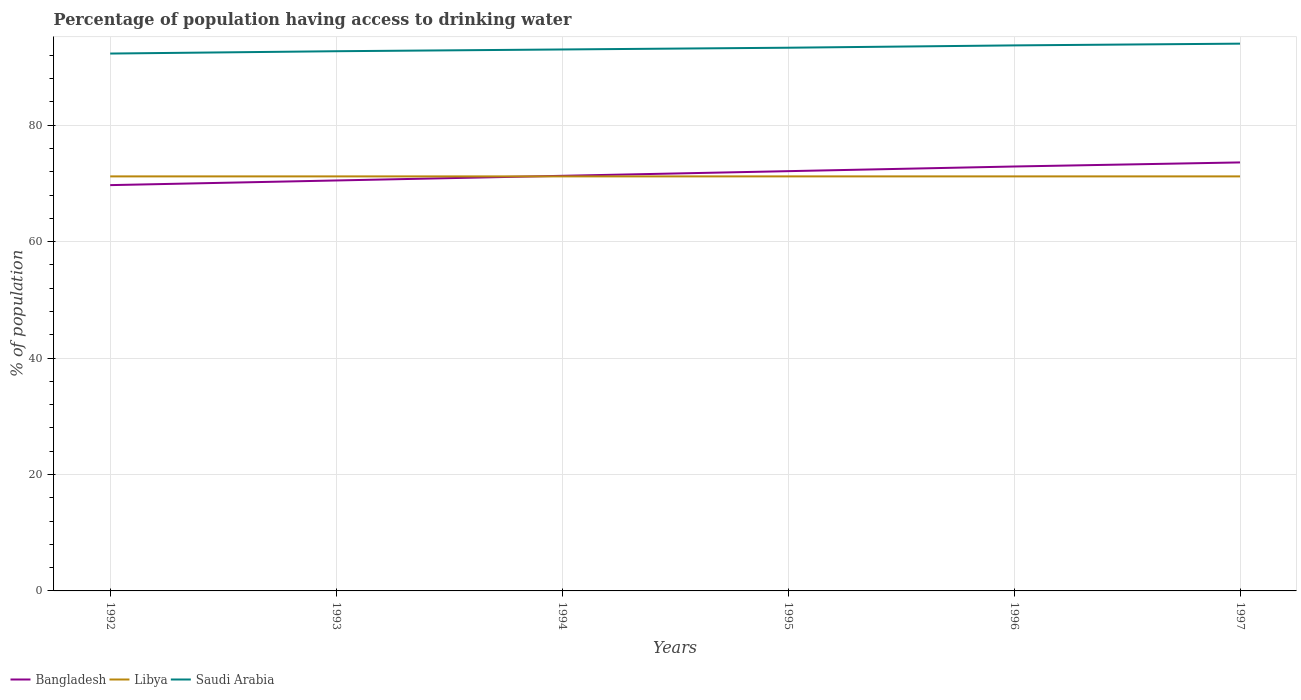How many different coloured lines are there?
Offer a terse response. 3. Is the number of lines equal to the number of legend labels?
Provide a short and direct response. Yes. Across all years, what is the maximum percentage of population having access to drinking water in Bangladesh?
Your answer should be very brief. 69.7. In which year was the percentage of population having access to drinking water in Saudi Arabia maximum?
Give a very brief answer. 1992. What is the total percentage of population having access to drinking water in Bangladesh in the graph?
Ensure brevity in your answer.  -1.6. What is the difference between the highest and the second highest percentage of population having access to drinking water in Saudi Arabia?
Your answer should be compact. 1.7. How many lines are there?
Your answer should be very brief. 3. What is the difference between two consecutive major ticks on the Y-axis?
Offer a terse response. 20. Are the values on the major ticks of Y-axis written in scientific E-notation?
Give a very brief answer. No. Does the graph contain any zero values?
Provide a succinct answer. No. Does the graph contain grids?
Offer a terse response. Yes. How are the legend labels stacked?
Offer a very short reply. Horizontal. What is the title of the graph?
Offer a terse response. Percentage of population having access to drinking water. Does "Middle East & North Africa (developing only)" appear as one of the legend labels in the graph?
Give a very brief answer. No. What is the label or title of the X-axis?
Make the answer very short. Years. What is the label or title of the Y-axis?
Your response must be concise. % of population. What is the % of population of Bangladesh in 1992?
Offer a very short reply. 69.7. What is the % of population in Libya in 1992?
Ensure brevity in your answer.  71.2. What is the % of population of Saudi Arabia in 1992?
Give a very brief answer. 92.3. What is the % of population in Bangladesh in 1993?
Provide a short and direct response. 70.5. What is the % of population in Libya in 1993?
Offer a very short reply. 71.2. What is the % of population of Saudi Arabia in 1993?
Offer a terse response. 92.7. What is the % of population in Bangladesh in 1994?
Ensure brevity in your answer.  71.3. What is the % of population in Libya in 1994?
Give a very brief answer. 71.2. What is the % of population of Saudi Arabia in 1994?
Give a very brief answer. 93. What is the % of population in Bangladesh in 1995?
Ensure brevity in your answer.  72.1. What is the % of population of Libya in 1995?
Your answer should be very brief. 71.2. What is the % of population in Saudi Arabia in 1995?
Offer a very short reply. 93.3. What is the % of population of Bangladesh in 1996?
Give a very brief answer. 72.9. What is the % of population of Libya in 1996?
Keep it short and to the point. 71.2. What is the % of population of Saudi Arabia in 1996?
Your response must be concise. 93.7. What is the % of population of Bangladesh in 1997?
Offer a terse response. 73.6. What is the % of population in Libya in 1997?
Your answer should be compact. 71.2. What is the % of population in Saudi Arabia in 1997?
Provide a short and direct response. 94. Across all years, what is the maximum % of population of Bangladesh?
Provide a succinct answer. 73.6. Across all years, what is the maximum % of population of Libya?
Your answer should be very brief. 71.2. Across all years, what is the maximum % of population in Saudi Arabia?
Offer a terse response. 94. Across all years, what is the minimum % of population in Bangladesh?
Offer a terse response. 69.7. Across all years, what is the minimum % of population in Libya?
Give a very brief answer. 71.2. Across all years, what is the minimum % of population in Saudi Arabia?
Provide a succinct answer. 92.3. What is the total % of population of Bangladesh in the graph?
Make the answer very short. 430.1. What is the total % of population in Libya in the graph?
Your response must be concise. 427.2. What is the total % of population of Saudi Arabia in the graph?
Your response must be concise. 559. What is the difference between the % of population in Bangladesh in 1992 and that in 1993?
Your response must be concise. -0.8. What is the difference between the % of population in Bangladesh in 1992 and that in 1994?
Offer a very short reply. -1.6. What is the difference between the % of population in Saudi Arabia in 1992 and that in 1994?
Your response must be concise. -0.7. What is the difference between the % of population of Libya in 1992 and that in 1995?
Your answer should be very brief. 0. What is the difference between the % of population in Libya in 1992 and that in 1996?
Provide a succinct answer. 0. What is the difference between the % of population of Saudi Arabia in 1992 and that in 1996?
Provide a succinct answer. -1.4. What is the difference between the % of population in Libya in 1992 and that in 1997?
Your answer should be compact. 0. What is the difference between the % of population of Bangladesh in 1993 and that in 1994?
Your response must be concise. -0.8. What is the difference between the % of population of Libya in 1993 and that in 1994?
Your answer should be very brief. 0. What is the difference between the % of population of Saudi Arabia in 1993 and that in 1994?
Provide a succinct answer. -0.3. What is the difference between the % of population in Bangladesh in 1993 and that in 1996?
Your answer should be very brief. -2.4. What is the difference between the % of population of Bangladesh in 1993 and that in 1997?
Give a very brief answer. -3.1. What is the difference between the % of population of Libya in 1993 and that in 1997?
Your response must be concise. 0. What is the difference between the % of population of Saudi Arabia in 1993 and that in 1997?
Provide a short and direct response. -1.3. What is the difference between the % of population in Bangladesh in 1994 and that in 1995?
Offer a terse response. -0.8. What is the difference between the % of population in Libya in 1994 and that in 1995?
Your response must be concise. 0. What is the difference between the % of population of Saudi Arabia in 1994 and that in 1995?
Offer a terse response. -0.3. What is the difference between the % of population of Bangladesh in 1994 and that in 1996?
Your answer should be compact. -1.6. What is the difference between the % of population in Libya in 1994 and that in 1996?
Give a very brief answer. 0. What is the difference between the % of population in Saudi Arabia in 1994 and that in 1996?
Offer a very short reply. -0.7. What is the difference between the % of population of Bangladesh in 1994 and that in 1997?
Keep it short and to the point. -2.3. What is the difference between the % of population in Libya in 1994 and that in 1997?
Your response must be concise. 0. What is the difference between the % of population of Bangladesh in 1995 and that in 1996?
Offer a terse response. -0.8. What is the difference between the % of population in Libya in 1995 and that in 1997?
Ensure brevity in your answer.  0. What is the difference between the % of population of Libya in 1996 and that in 1997?
Your answer should be very brief. 0. What is the difference between the % of population in Saudi Arabia in 1996 and that in 1997?
Make the answer very short. -0.3. What is the difference between the % of population in Libya in 1992 and the % of population in Saudi Arabia in 1993?
Keep it short and to the point. -21.5. What is the difference between the % of population in Bangladesh in 1992 and the % of population in Libya in 1994?
Offer a very short reply. -1.5. What is the difference between the % of population in Bangladesh in 1992 and the % of population in Saudi Arabia in 1994?
Provide a short and direct response. -23.3. What is the difference between the % of population of Libya in 1992 and the % of population of Saudi Arabia in 1994?
Your answer should be very brief. -21.8. What is the difference between the % of population of Bangladesh in 1992 and the % of population of Saudi Arabia in 1995?
Your answer should be very brief. -23.6. What is the difference between the % of population in Libya in 1992 and the % of population in Saudi Arabia in 1995?
Provide a succinct answer. -22.1. What is the difference between the % of population of Bangladesh in 1992 and the % of population of Saudi Arabia in 1996?
Give a very brief answer. -24. What is the difference between the % of population of Libya in 1992 and the % of population of Saudi Arabia in 1996?
Provide a succinct answer. -22.5. What is the difference between the % of population of Bangladesh in 1992 and the % of population of Saudi Arabia in 1997?
Keep it short and to the point. -24.3. What is the difference between the % of population in Libya in 1992 and the % of population in Saudi Arabia in 1997?
Ensure brevity in your answer.  -22.8. What is the difference between the % of population in Bangladesh in 1993 and the % of population in Saudi Arabia in 1994?
Your answer should be compact. -22.5. What is the difference between the % of population of Libya in 1993 and the % of population of Saudi Arabia in 1994?
Make the answer very short. -21.8. What is the difference between the % of population of Bangladesh in 1993 and the % of population of Libya in 1995?
Make the answer very short. -0.7. What is the difference between the % of population of Bangladesh in 1993 and the % of population of Saudi Arabia in 1995?
Give a very brief answer. -22.8. What is the difference between the % of population of Libya in 1993 and the % of population of Saudi Arabia in 1995?
Offer a very short reply. -22.1. What is the difference between the % of population of Bangladesh in 1993 and the % of population of Libya in 1996?
Your response must be concise. -0.7. What is the difference between the % of population of Bangladesh in 1993 and the % of population of Saudi Arabia in 1996?
Your answer should be compact. -23.2. What is the difference between the % of population of Libya in 1993 and the % of population of Saudi Arabia in 1996?
Offer a very short reply. -22.5. What is the difference between the % of population of Bangladesh in 1993 and the % of population of Saudi Arabia in 1997?
Offer a terse response. -23.5. What is the difference between the % of population in Libya in 1993 and the % of population in Saudi Arabia in 1997?
Your answer should be compact. -22.8. What is the difference between the % of population of Bangladesh in 1994 and the % of population of Saudi Arabia in 1995?
Your response must be concise. -22. What is the difference between the % of population in Libya in 1994 and the % of population in Saudi Arabia in 1995?
Your answer should be compact. -22.1. What is the difference between the % of population of Bangladesh in 1994 and the % of population of Libya in 1996?
Your answer should be very brief. 0.1. What is the difference between the % of population of Bangladesh in 1994 and the % of population of Saudi Arabia in 1996?
Offer a very short reply. -22.4. What is the difference between the % of population of Libya in 1994 and the % of population of Saudi Arabia in 1996?
Your answer should be very brief. -22.5. What is the difference between the % of population of Bangladesh in 1994 and the % of population of Saudi Arabia in 1997?
Offer a terse response. -22.7. What is the difference between the % of population in Libya in 1994 and the % of population in Saudi Arabia in 1997?
Your answer should be compact. -22.8. What is the difference between the % of population of Bangladesh in 1995 and the % of population of Saudi Arabia in 1996?
Make the answer very short. -21.6. What is the difference between the % of population in Libya in 1995 and the % of population in Saudi Arabia in 1996?
Give a very brief answer. -22.5. What is the difference between the % of population in Bangladesh in 1995 and the % of population in Libya in 1997?
Offer a terse response. 0.9. What is the difference between the % of population of Bangladesh in 1995 and the % of population of Saudi Arabia in 1997?
Provide a short and direct response. -21.9. What is the difference between the % of population in Libya in 1995 and the % of population in Saudi Arabia in 1997?
Offer a terse response. -22.8. What is the difference between the % of population in Bangladesh in 1996 and the % of population in Libya in 1997?
Provide a succinct answer. 1.7. What is the difference between the % of population of Bangladesh in 1996 and the % of population of Saudi Arabia in 1997?
Make the answer very short. -21.1. What is the difference between the % of population of Libya in 1996 and the % of population of Saudi Arabia in 1997?
Offer a very short reply. -22.8. What is the average % of population of Bangladesh per year?
Give a very brief answer. 71.68. What is the average % of population of Libya per year?
Offer a terse response. 71.2. What is the average % of population in Saudi Arabia per year?
Offer a terse response. 93.17. In the year 1992, what is the difference between the % of population in Bangladesh and % of population in Saudi Arabia?
Your answer should be compact. -22.6. In the year 1992, what is the difference between the % of population of Libya and % of population of Saudi Arabia?
Keep it short and to the point. -21.1. In the year 1993, what is the difference between the % of population in Bangladesh and % of population in Libya?
Ensure brevity in your answer.  -0.7. In the year 1993, what is the difference between the % of population in Bangladesh and % of population in Saudi Arabia?
Ensure brevity in your answer.  -22.2. In the year 1993, what is the difference between the % of population of Libya and % of population of Saudi Arabia?
Offer a very short reply. -21.5. In the year 1994, what is the difference between the % of population in Bangladesh and % of population in Saudi Arabia?
Provide a succinct answer. -21.7. In the year 1994, what is the difference between the % of population in Libya and % of population in Saudi Arabia?
Your answer should be compact. -21.8. In the year 1995, what is the difference between the % of population in Bangladesh and % of population in Libya?
Offer a terse response. 0.9. In the year 1995, what is the difference between the % of population of Bangladesh and % of population of Saudi Arabia?
Provide a succinct answer. -21.2. In the year 1995, what is the difference between the % of population of Libya and % of population of Saudi Arabia?
Provide a succinct answer. -22.1. In the year 1996, what is the difference between the % of population in Bangladesh and % of population in Saudi Arabia?
Provide a succinct answer. -20.8. In the year 1996, what is the difference between the % of population of Libya and % of population of Saudi Arabia?
Give a very brief answer. -22.5. In the year 1997, what is the difference between the % of population in Bangladesh and % of population in Saudi Arabia?
Your response must be concise. -20.4. In the year 1997, what is the difference between the % of population in Libya and % of population in Saudi Arabia?
Offer a terse response. -22.8. What is the ratio of the % of population in Bangladesh in 1992 to that in 1993?
Give a very brief answer. 0.99. What is the ratio of the % of population of Libya in 1992 to that in 1993?
Provide a succinct answer. 1. What is the ratio of the % of population of Bangladesh in 1992 to that in 1994?
Give a very brief answer. 0.98. What is the ratio of the % of population in Libya in 1992 to that in 1994?
Provide a succinct answer. 1. What is the ratio of the % of population of Bangladesh in 1992 to that in 1995?
Offer a very short reply. 0.97. What is the ratio of the % of population in Libya in 1992 to that in 1995?
Give a very brief answer. 1. What is the ratio of the % of population in Saudi Arabia in 1992 to that in 1995?
Provide a short and direct response. 0.99. What is the ratio of the % of population in Bangladesh in 1992 to that in 1996?
Your answer should be compact. 0.96. What is the ratio of the % of population in Libya in 1992 to that in 1996?
Ensure brevity in your answer.  1. What is the ratio of the % of population in Saudi Arabia in 1992 to that in 1996?
Make the answer very short. 0.99. What is the ratio of the % of population in Bangladesh in 1992 to that in 1997?
Make the answer very short. 0.95. What is the ratio of the % of population in Saudi Arabia in 1992 to that in 1997?
Provide a short and direct response. 0.98. What is the ratio of the % of population in Bangladesh in 1993 to that in 1994?
Your answer should be compact. 0.99. What is the ratio of the % of population of Bangladesh in 1993 to that in 1995?
Provide a succinct answer. 0.98. What is the ratio of the % of population of Libya in 1993 to that in 1995?
Ensure brevity in your answer.  1. What is the ratio of the % of population in Saudi Arabia in 1993 to that in 1995?
Keep it short and to the point. 0.99. What is the ratio of the % of population in Bangladesh in 1993 to that in 1996?
Ensure brevity in your answer.  0.97. What is the ratio of the % of population in Libya in 1993 to that in 1996?
Your answer should be very brief. 1. What is the ratio of the % of population of Saudi Arabia in 1993 to that in 1996?
Keep it short and to the point. 0.99. What is the ratio of the % of population in Bangladesh in 1993 to that in 1997?
Keep it short and to the point. 0.96. What is the ratio of the % of population in Saudi Arabia in 1993 to that in 1997?
Keep it short and to the point. 0.99. What is the ratio of the % of population of Bangladesh in 1994 to that in 1995?
Offer a very short reply. 0.99. What is the ratio of the % of population of Saudi Arabia in 1994 to that in 1995?
Make the answer very short. 1. What is the ratio of the % of population in Bangladesh in 1994 to that in 1996?
Keep it short and to the point. 0.98. What is the ratio of the % of population of Saudi Arabia in 1994 to that in 1996?
Provide a succinct answer. 0.99. What is the ratio of the % of population in Bangladesh in 1994 to that in 1997?
Give a very brief answer. 0.97. What is the ratio of the % of population of Libya in 1994 to that in 1997?
Provide a succinct answer. 1. What is the ratio of the % of population of Saudi Arabia in 1994 to that in 1997?
Offer a very short reply. 0.99. What is the ratio of the % of population of Bangladesh in 1995 to that in 1996?
Give a very brief answer. 0.99. What is the ratio of the % of population of Saudi Arabia in 1995 to that in 1996?
Your answer should be compact. 1. What is the ratio of the % of population in Bangladesh in 1995 to that in 1997?
Provide a succinct answer. 0.98. What is the ratio of the % of population of Saudi Arabia in 1996 to that in 1997?
Give a very brief answer. 1. What is the difference between the highest and the second highest % of population in Bangladesh?
Give a very brief answer. 0.7. What is the difference between the highest and the second highest % of population of Libya?
Your response must be concise. 0. What is the difference between the highest and the second highest % of population in Saudi Arabia?
Give a very brief answer. 0.3. What is the difference between the highest and the lowest % of population in Bangladesh?
Provide a short and direct response. 3.9. 